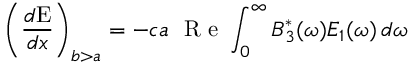Convert formula to latex. <formula><loc_0><loc_0><loc_500><loc_500>\left ( \frac { d { E } } { d x } \right ) _ { b > a } = - c a R e \int _ { 0 } ^ { \infty } B _ { 3 } ^ { \ast } ( \omega ) E _ { 1 } ( \omega ) \, d \omega</formula> 